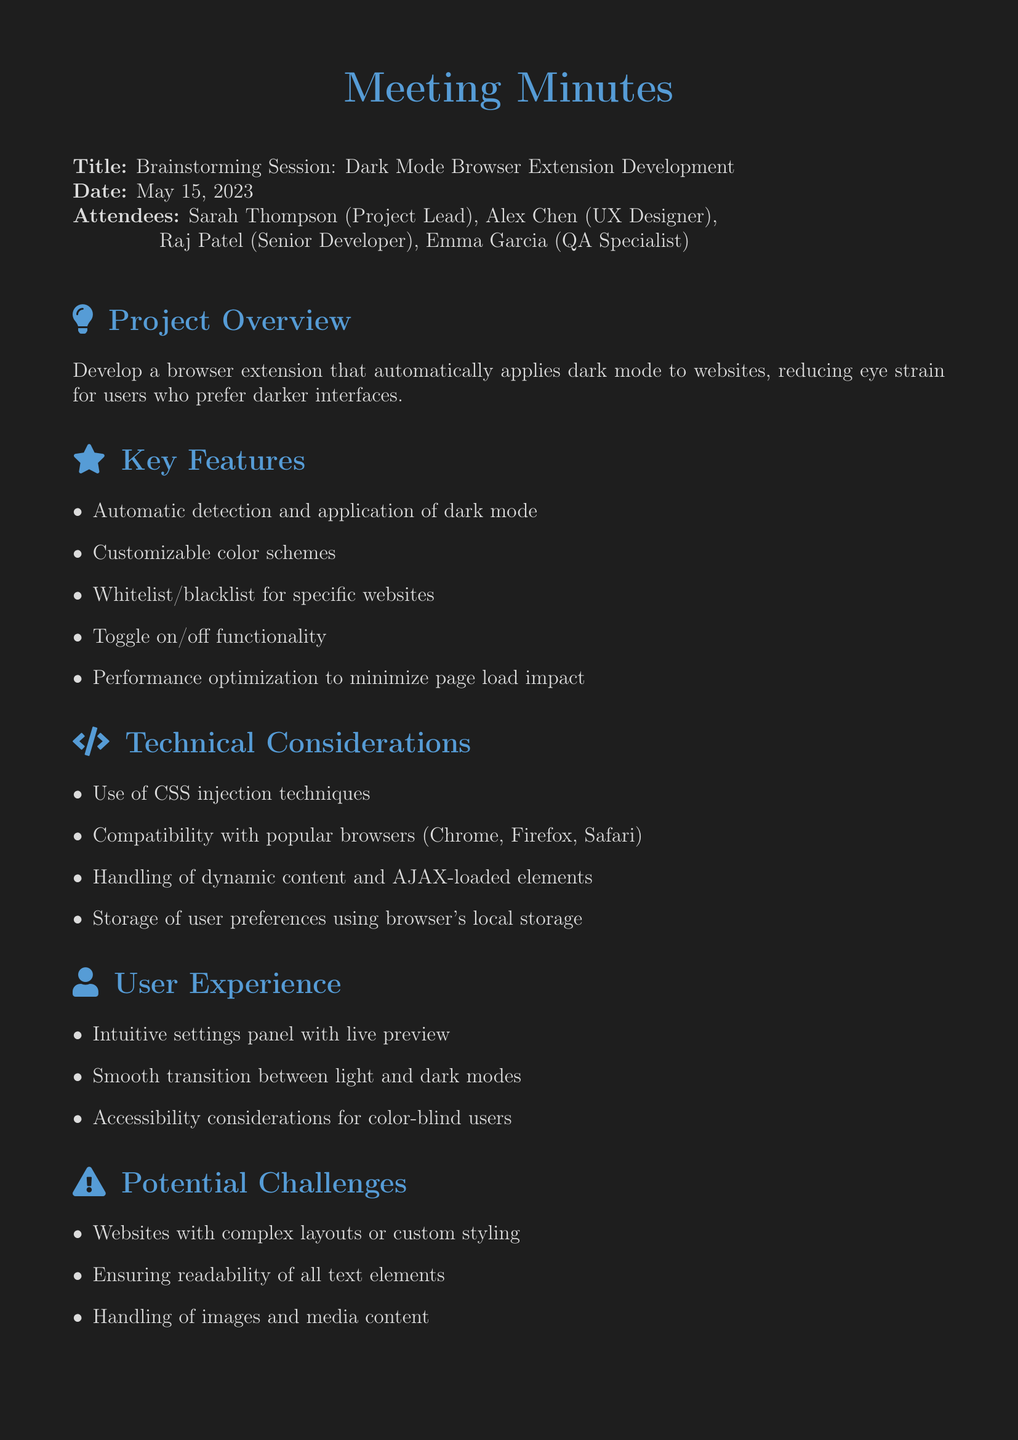What is the meeting title? The meeting title is stated at the top of the document.
Answer: Brainstorming Session: Dark Mode Browser Extension Development Who is the project lead? The document lists the attendees and their roles at the beginning.
Answer: Sarah Thompson What is one of the key features of the extension? The document provides a bullet list of key features under a dedicated section.
Answer: Automatic detection and application of dark mode Which browsers should the extension be compatible with? The technical considerations section mentions specific browsers for compatibility.
Answer: Chrome, Firefox, Safari What is a potential challenge mentioned in the meeting? The list under potential challenges highlights different issues the project may face.
Answer: Websites with complex layouts or custom styling What should be created as a next step? The next steps section outlines actions to be taken following the meeting.
Answer: Create project timeline and milestones How many attendees were present at the meeting? The number of attendees can be counted from the list provided in the document.
Answer: Four What is one of the considerations for user experience? The document mentions multiple points regarding user experience.
Answer: Intuitive settings panel with live preview 